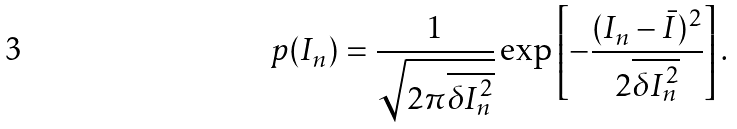Convert formula to latex. <formula><loc_0><loc_0><loc_500><loc_500>p ( I _ { n } ) = \frac { 1 } { \sqrt { 2 \pi \overline { \delta I _ { n } ^ { 2 } } } } \exp \left [ - \frac { ( I _ { n } - \bar { I } ) ^ { 2 } } { 2 \overline { \delta I _ { n } ^ { 2 } } } \right ] .</formula> 